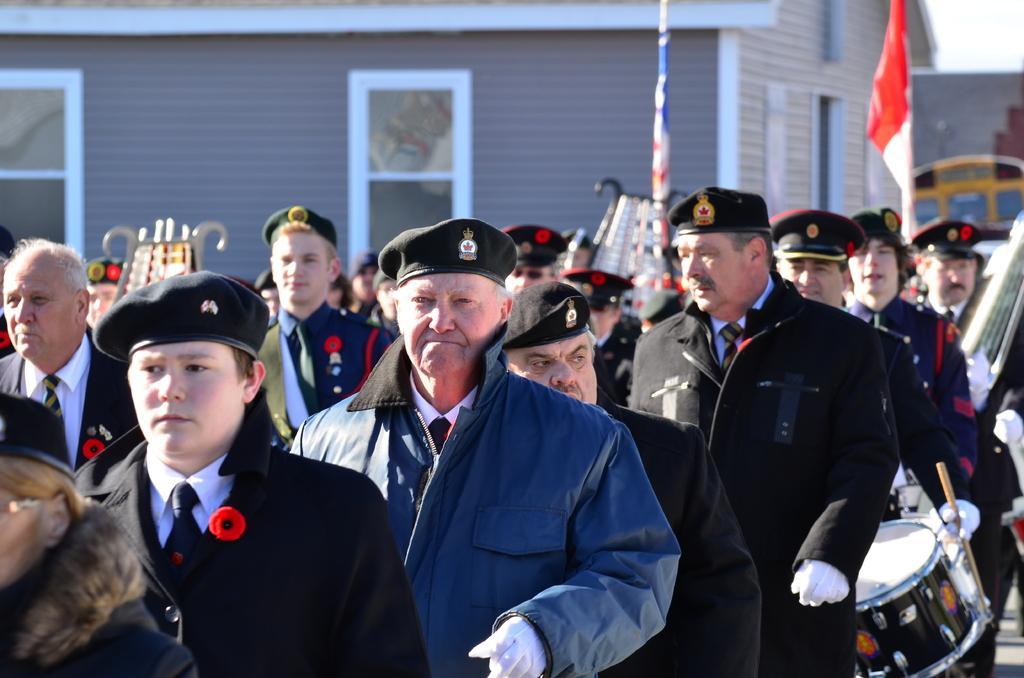Can you describe this image briefly? In this image i can see a group of people standing at the background i can see a flag, a building, a window. 